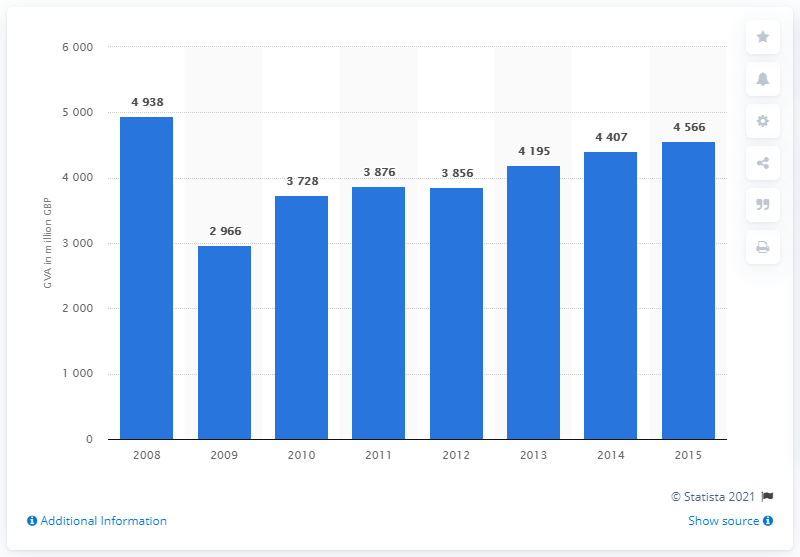Give some essential details in this illustration. In 2015, the gross value added of the TV programming and broadcasting sector was approximately $45,660. 